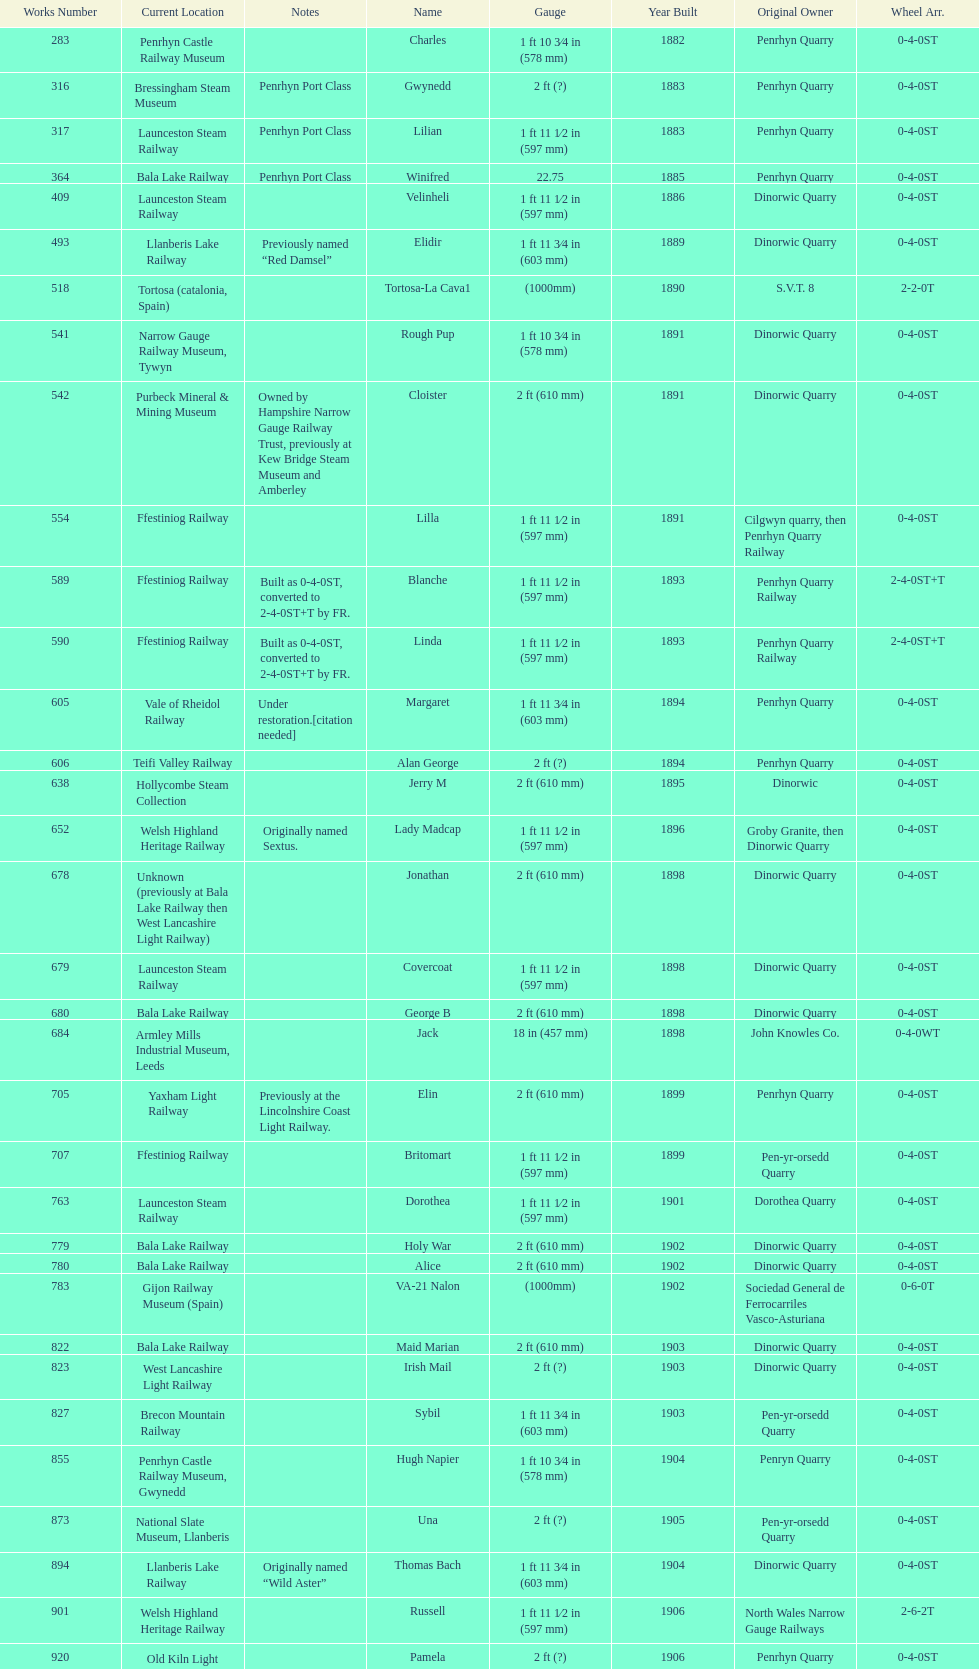What is the total number of preserved hunslet narrow gauge locomotives currently located in ffestiniog railway 554. 